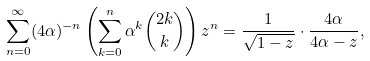<formula> <loc_0><loc_0><loc_500><loc_500>\sum _ { n = 0 } ^ { \infty } ( 4 \alpha ) ^ { - n } \left ( \sum _ { k = 0 } ^ { n } \alpha ^ { k } \binom { 2 k } { k } \right ) z ^ { n } = \frac { 1 } { \sqrt { 1 - z } } \cdot \frac { 4 \alpha } { 4 \alpha - z } ,</formula> 